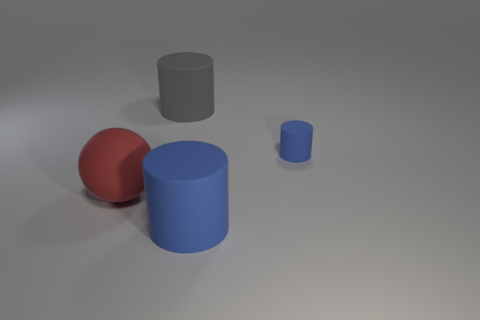Subtract all blue cylinders. How many cylinders are left? 1 Subtract all gray cylinders. How many cylinders are left? 2 Subtract 1 balls. How many balls are left? 0 Subtract all cylinders. How many objects are left? 1 Subtract all green cubes. How many blue cylinders are left? 2 Add 1 big brown shiny blocks. How many big brown shiny blocks exist? 1 Add 3 red spheres. How many objects exist? 7 Subtract 0 blue balls. How many objects are left? 4 Subtract all green cylinders. Subtract all yellow balls. How many cylinders are left? 3 Subtract all big red objects. Subtract all large red balls. How many objects are left? 2 